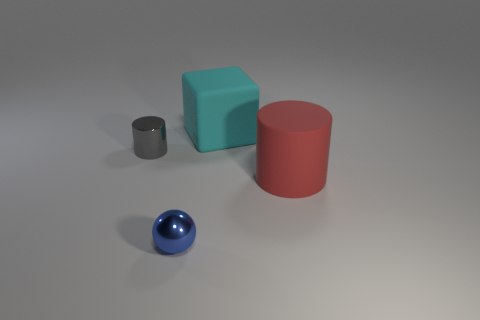Add 4 tiny gray metal cylinders. How many objects exist? 8 Subtract 1 cylinders. How many cylinders are left? 1 Subtract all balls. How many objects are left? 3 Subtract all blue spheres. How many brown cubes are left? 0 Subtract all red matte objects. Subtract all cylinders. How many objects are left? 1 Add 4 large cyan rubber cubes. How many large cyan rubber cubes are left? 5 Add 2 large red cylinders. How many large red cylinders exist? 3 Subtract 0 purple cylinders. How many objects are left? 4 Subtract all purple blocks. Subtract all purple cylinders. How many blocks are left? 1 